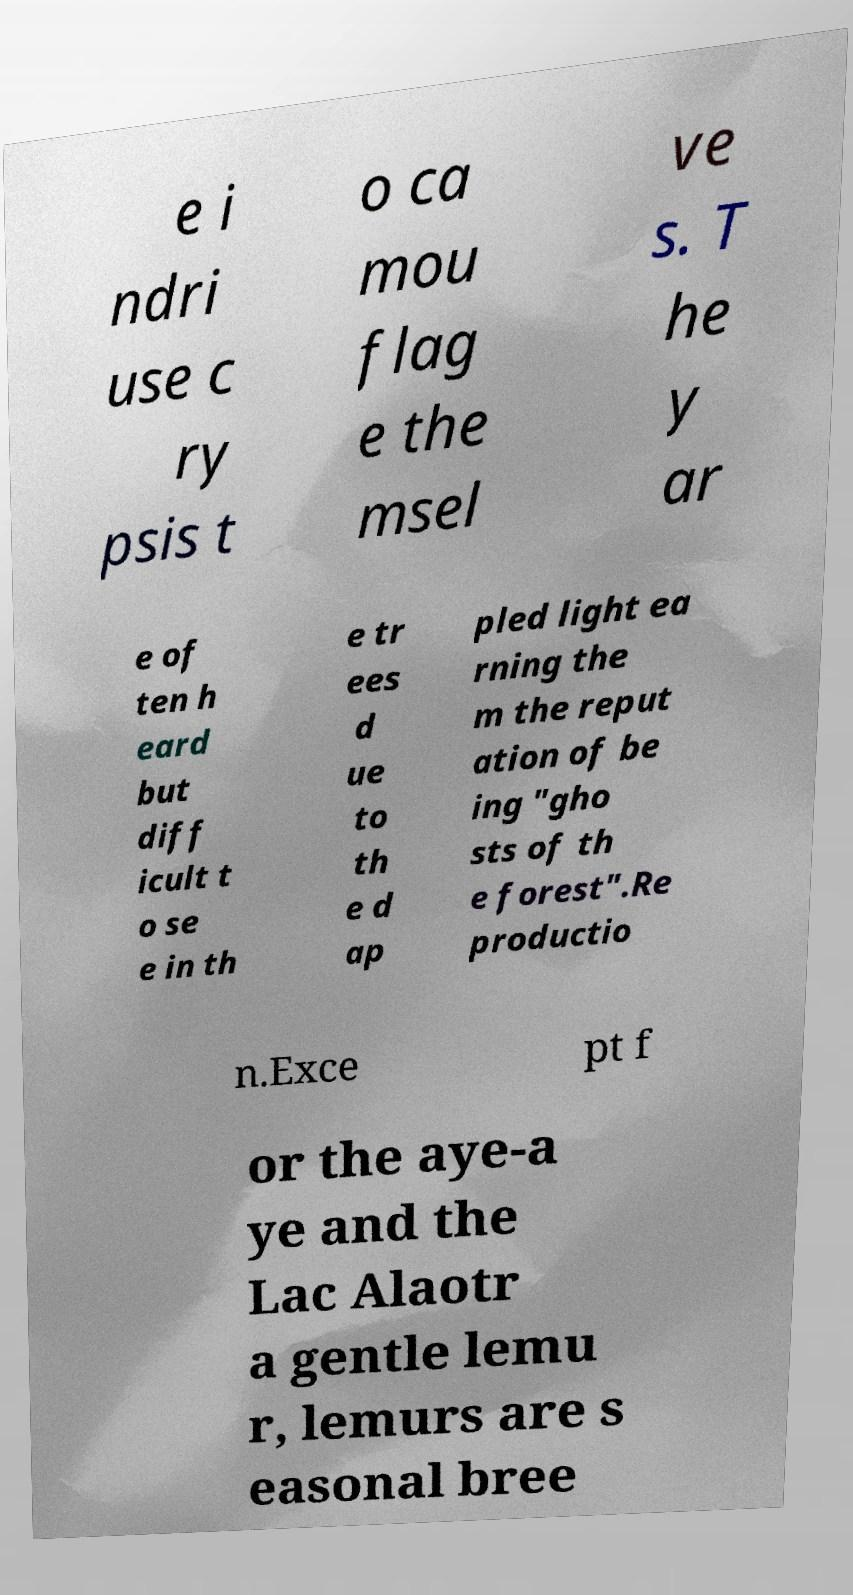Can you read and provide the text displayed in the image?This photo seems to have some interesting text. Can you extract and type it out for me? e i ndri use c ry psis t o ca mou flag e the msel ve s. T he y ar e of ten h eard but diff icult t o se e in th e tr ees d ue to th e d ap pled light ea rning the m the reput ation of be ing "gho sts of th e forest".Re productio n.Exce pt f or the aye-a ye and the Lac Alaotr a gentle lemu r, lemurs are s easonal bree 